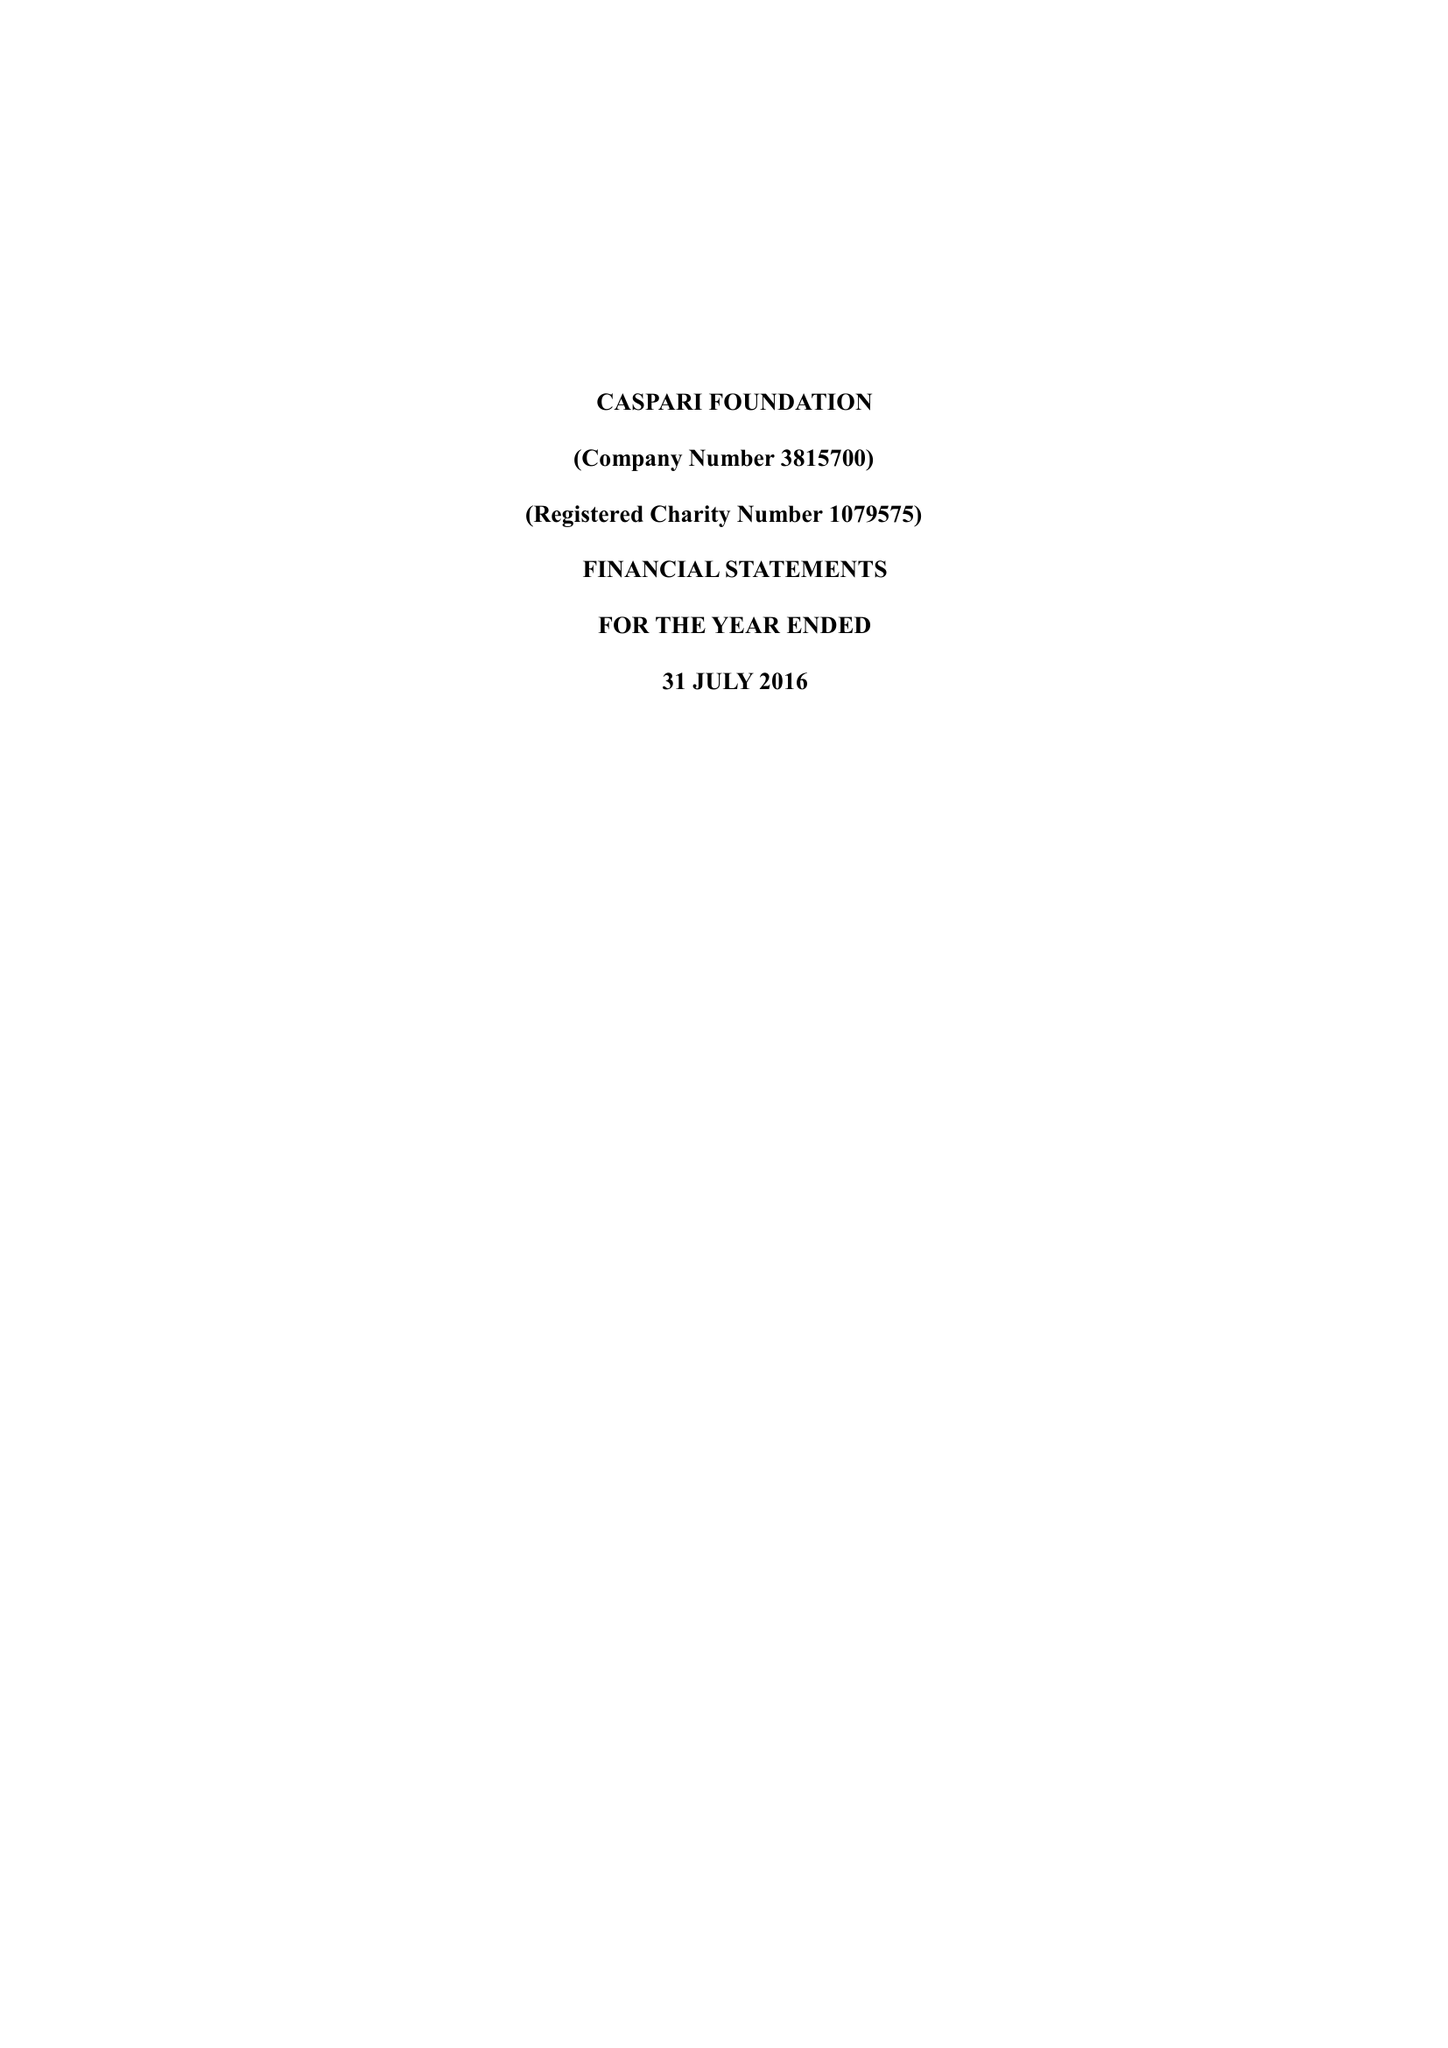What is the value for the charity_name?
Answer the question using a single word or phrase. Caspari Foundation 